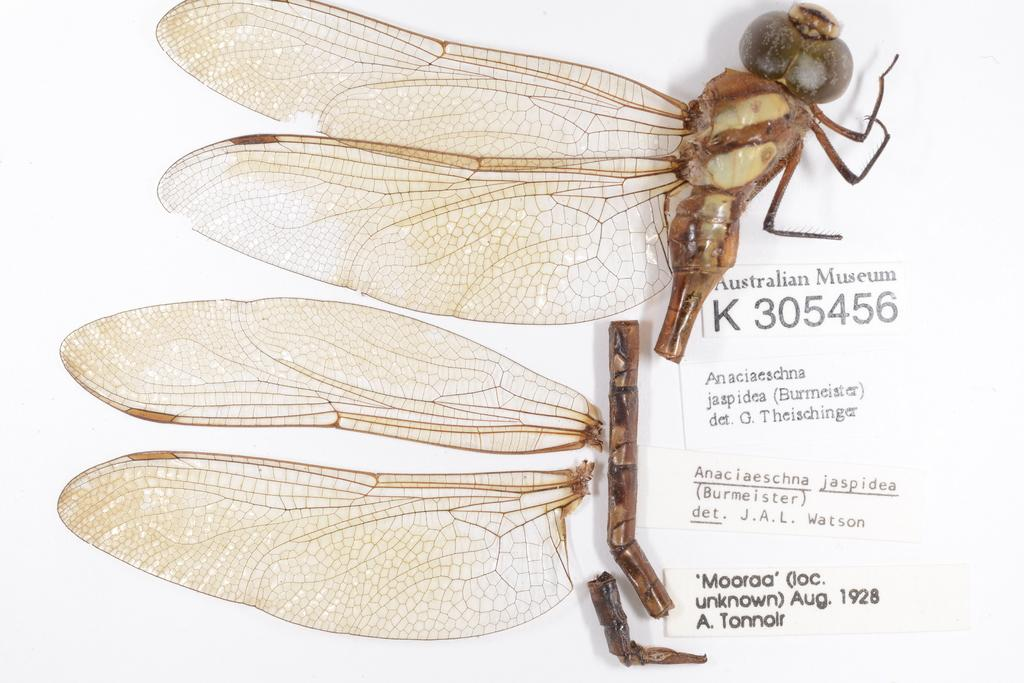What is depicted in the image that has multiple pieces? There are pieces of a dragonfly in the image. What can be found on the right side of the image? There are white stickers with text on the right side of the image. What color is the background of the image? The background of the image is white in color. What direction are the plants growing in the image? There are no plants present in the image. 